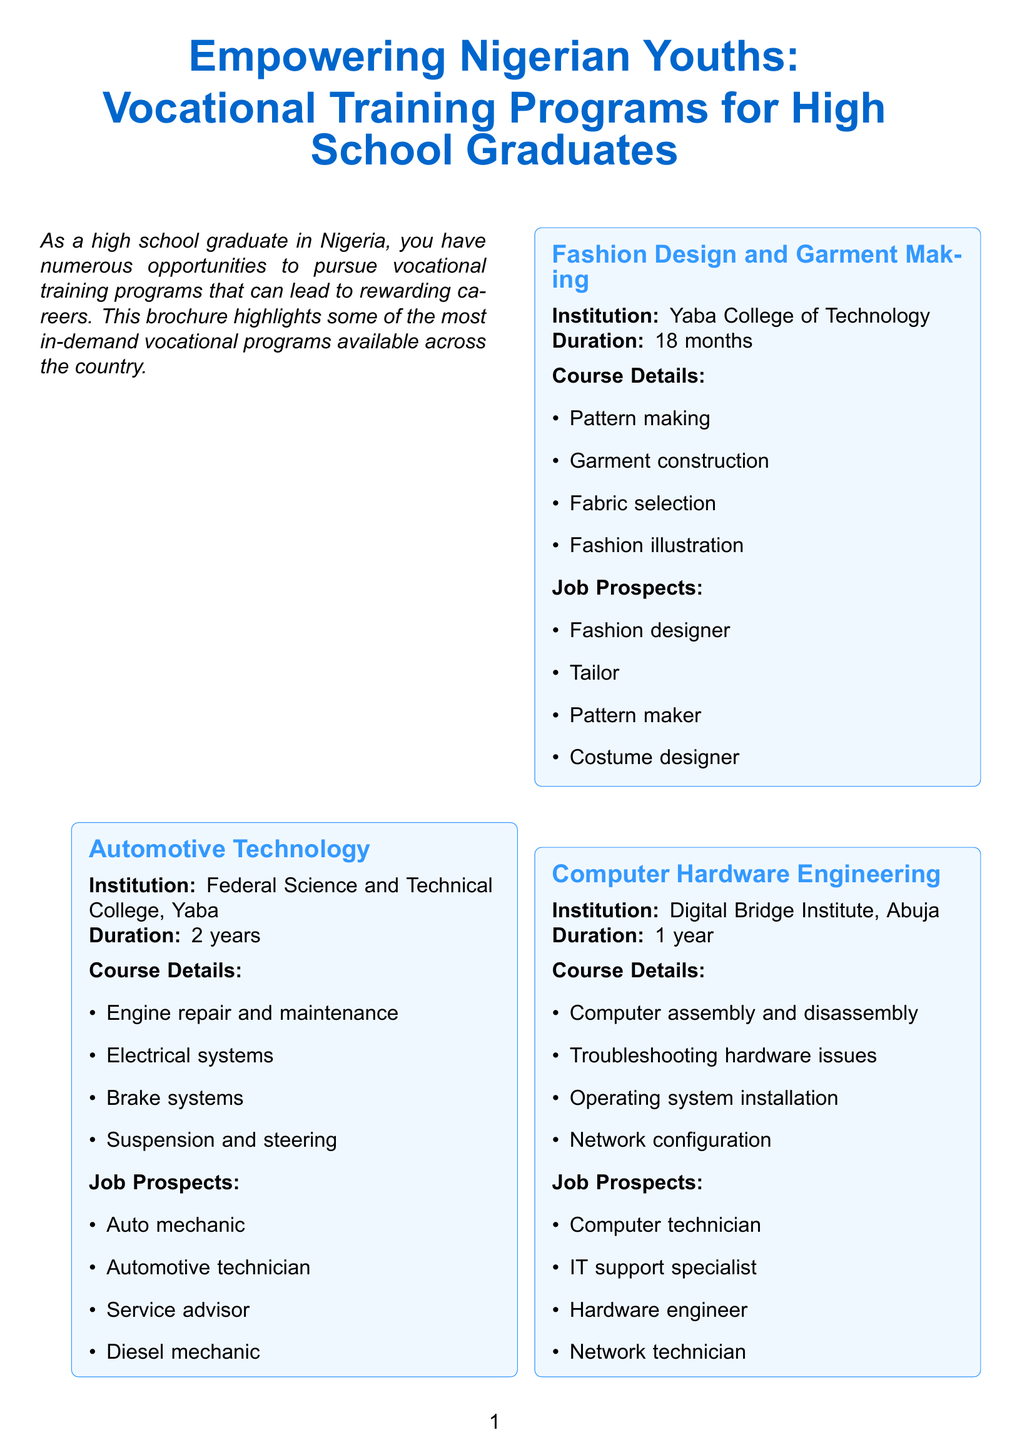What is the title of the brochure? The title is explicitly stated at the beginning of the document.
Answer: Empowering Nigerian Youths: Vocational Training Programs for High School Graduates How long is the Automotive Technology program? The duration details for each program are listed in the document.
Answer: 2 years Which institution offers the Computer Hardware Engineering program? The document specifies the institutions for each vocational program.
Answer: Digital Bridge Institute, Abuja What are the job prospects for a graduate of Fashion Design and Garment Making? The document lists potential job positions for each program.
Answer: Fashion designer, Tailor, Pattern maker, Costume designer What is one of the funding options provided for vocational training? The additional information section lists various funding options available.
Answer: Federal Government N-Power Program Which vocational program has the shortest duration? By comparing the durations of all programs listed, one can identify the shortest.
Answer: Computer Hardware Engineering What is the main purpose of career counseling according to the brochure? The document describes services offered for career guidance.
Answer: Free career counseling and guidance What are the job placement assistance services mentioned? The document specifies the services available after program completion.
Answer: Job placement assistance How many vocational training programs are listed in the brochure? Counting the programs enumerated in the document provides the total.
Answer: 5 